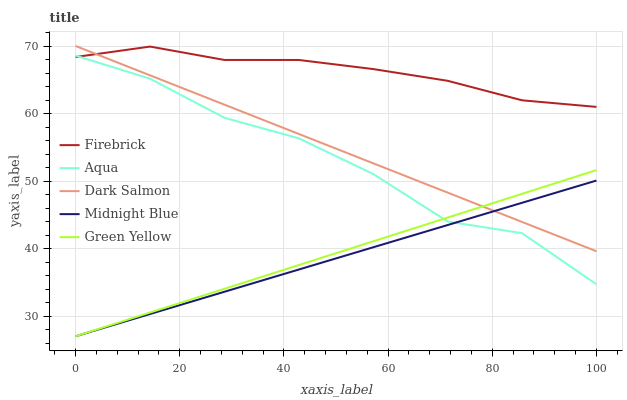Does Midnight Blue have the minimum area under the curve?
Answer yes or no. Yes. Does Firebrick have the maximum area under the curve?
Answer yes or no. Yes. Does Green Yellow have the minimum area under the curve?
Answer yes or no. No. Does Green Yellow have the maximum area under the curve?
Answer yes or no. No. Is Green Yellow the smoothest?
Answer yes or no. Yes. Is Aqua the roughest?
Answer yes or no. Yes. Is Aqua the smoothest?
Answer yes or no. No. Is Green Yellow the roughest?
Answer yes or no. No. Does Green Yellow have the lowest value?
Answer yes or no. Yes. Does Aqua have the lowest value?
Answer yes or no. No. Does Dark Salmon have the highest value?
Answer yes or no. Yes. Does Green Yellow have the highest value?
Answer yes or no. No. Is Aqua less than Dark Salmon?
Answer yes or no. Yes. Is Dark Salmon greater than Aqua?
Answer yes or no. Yes. Does Midnight Blue intersect Green Yellow?
Answer yes or no. Yes. Is Midnight Blue less than Green Yellow?
Answer yes or no. No. Is Midnight Blue greater than Green Yellow?
Answer yes or no. No. Does Aqua intersect Dark Salmon?
Answer yes or no. No. 